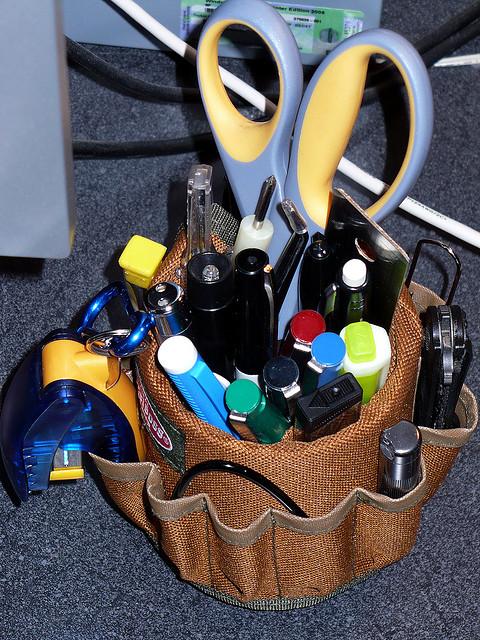Is the item shown from a distance or up close?
Give a very brief answer. Up close. Which tool/item in the container is the largest?
Short answer required. Scissors. How many pairs of scissors are visible in this photo?
Concise answer only. 1. 